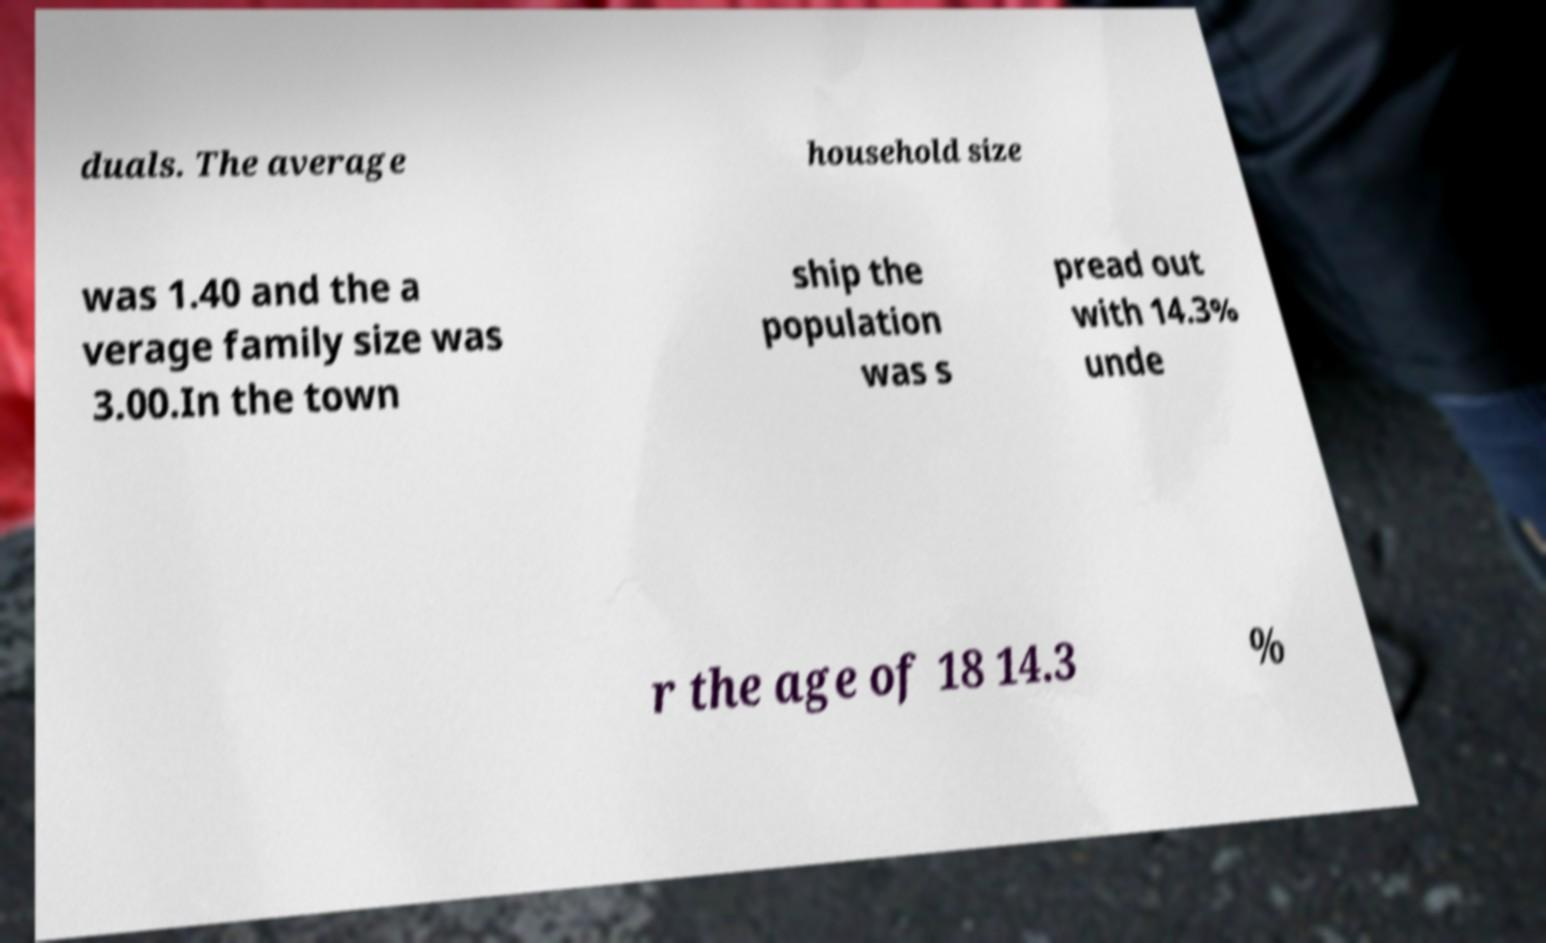I need the written content from this picture converted into text. Can you do that? duals. The average household size was 1.40 and the a verage family size was 3.00.In the town ship the population was s pread out with 14.3% unde r the age of 18 14.3 % 